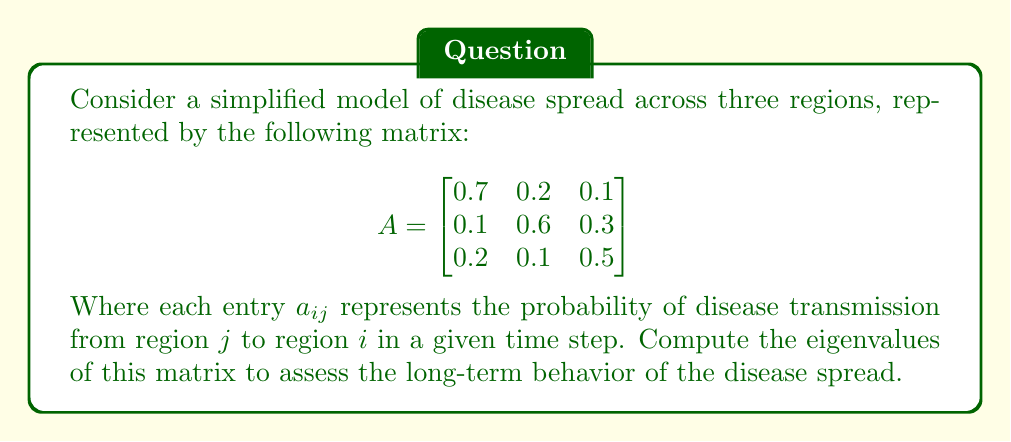Teach me how to tackle this problem. To find the eigenvalues of matrix $A$, we need to solve the characteristic equation:

$$\det(A - \lambda I) = 0$$

Where $I$ is the 3x3 identity matrix and $\lambda$ represents the eigenvalues.

Step 1: Set up the characteristic equation:
$$\begin{vmatrix}
0.7 - \lambda & 0.2 & 0.1 \\
0.1 & 0.6 - \lambda & 0.3 \\
0.2 & 0.1 & 0.5 - \lambda
\end{vmatrix} = 0$$

Step 2: Expand the determinant:
$$(0.7 - \lambda)[(0.6 - \lambda)(0.5 - \lambda) - 0.03] - 0.2[0.1(0.5 - \lambda) - 0.3(0.2)] + 0.1[0.1(0.1) - 0.2(0.6 - \lambda)] = 0$$

Step 3: Simplify:
$$\lambda^3 - 1.8\lambda^2 + 0.83\lambda - 0.12 = 0$$

Step 4: Solve the cubic equation. This can be done using the cubic formula or numerical methods. Using a computer algebra system, we find the roots:

$$\lambda_1 \approx 1.0000$$
$$\lambda_2 \approx 0.4142$$
$$\lambda_3 \approx 0.3858$$

The largest eigenvalue (spectral radius) is 1, which indicates that the disease will persist in the long term. The other eigenvalues provide information about the rates of decay for different modes of the disease spread.
Answer: $\lambda_1 \approx 1.0000$, $\lambda_2 \approx 0.4142$, $\lambda_3 \approx 0.3858$ 